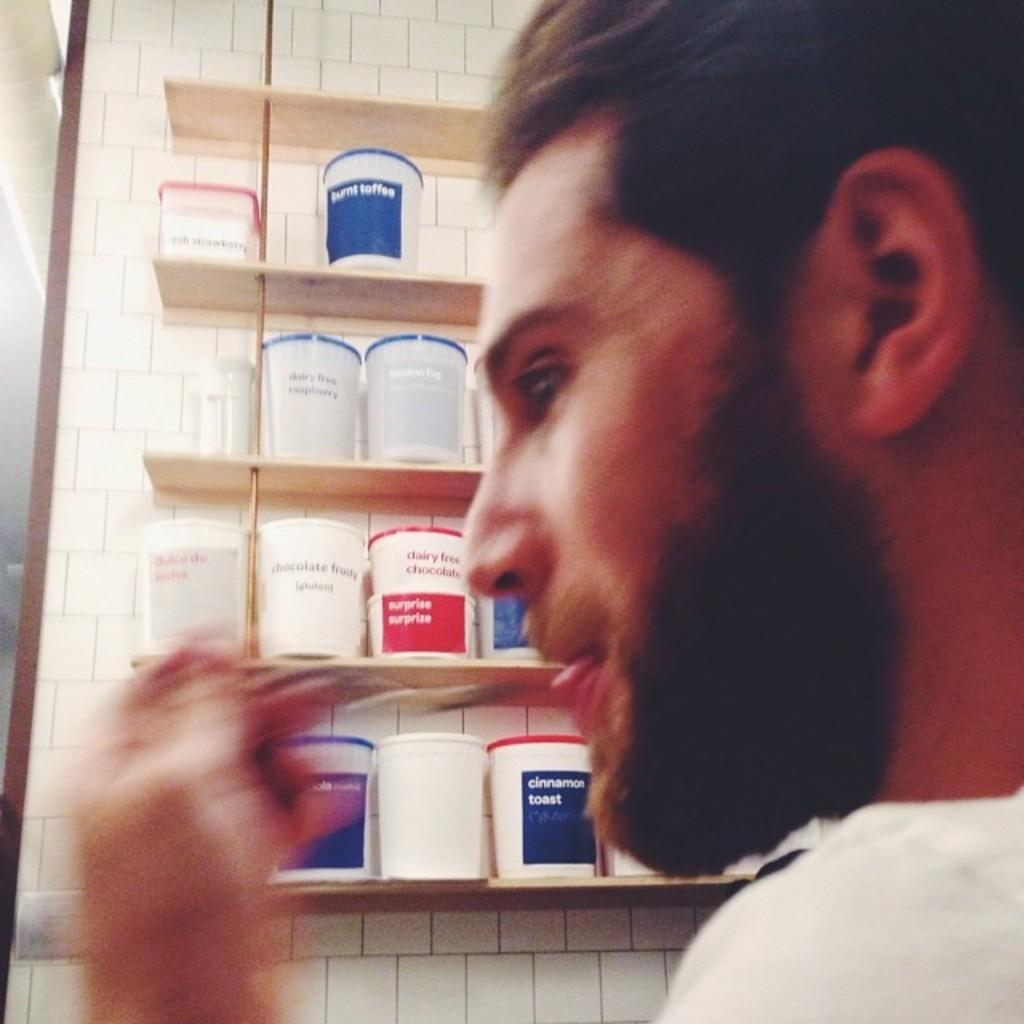What is the person in the image wearing? The person in the image is wearing a white dress. What can be seen on the shelf in the image? There are colorful boxes on a shelf in the image. What type of hose is being used to support the person's stomach in the image? There is no hose or support for the person's stomach visible in the image. 